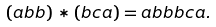Convert formula to latex. <formula><loc_0><loc_0><loc_500><loc_500>( a b b ) * ( b c a ) = a b b b c a .</formula> 